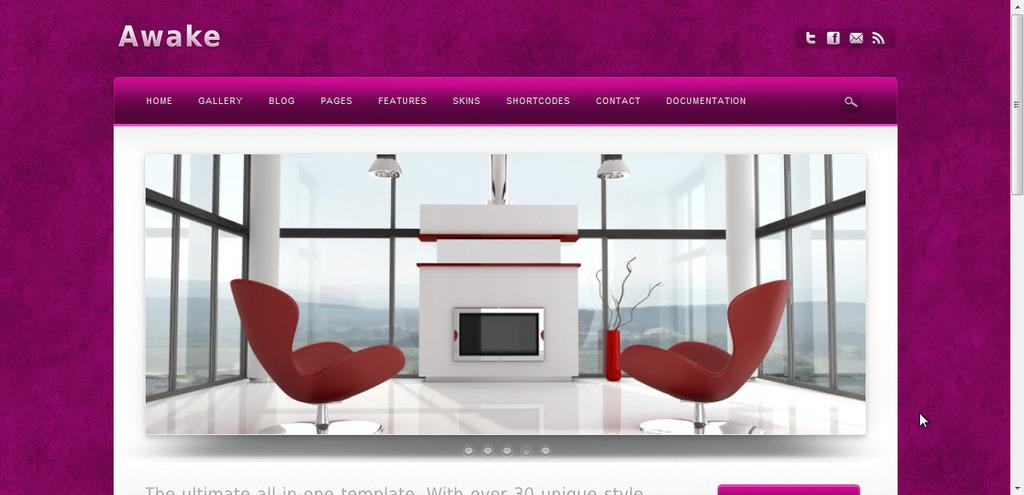Provide a one-sentence caption for the provided image. A website called Awake showing two red chairs and a fireplace in front of the chair in a glass room. 